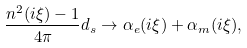<formula> <loc_0><loc_0><loc_500><loc_500>\frac { n ^ { 2 } ( i \xi ) - 1 } { 4 \pi } d _ { s } \rightarrow \alpha _ { e } ( i \xi ) + \alpha _ { m } ( i \xi ) ,</formula> 